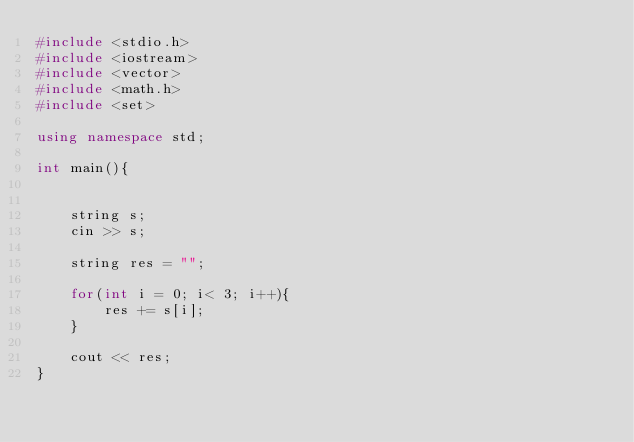Convert code to text. <code><loc_0><loc_0><loc_500><loc_500><_C++_>#include <stdio.h>
#include <iostream>
#include <vector>
#include <math.h>
#include <set>

using namespace std;

int main(){    


    string s;
    cin >> s;

    string res = "";

    for(int i = 0; i< 3; i++){
        res += s[i];
    }

    cout << res;
}</code> 